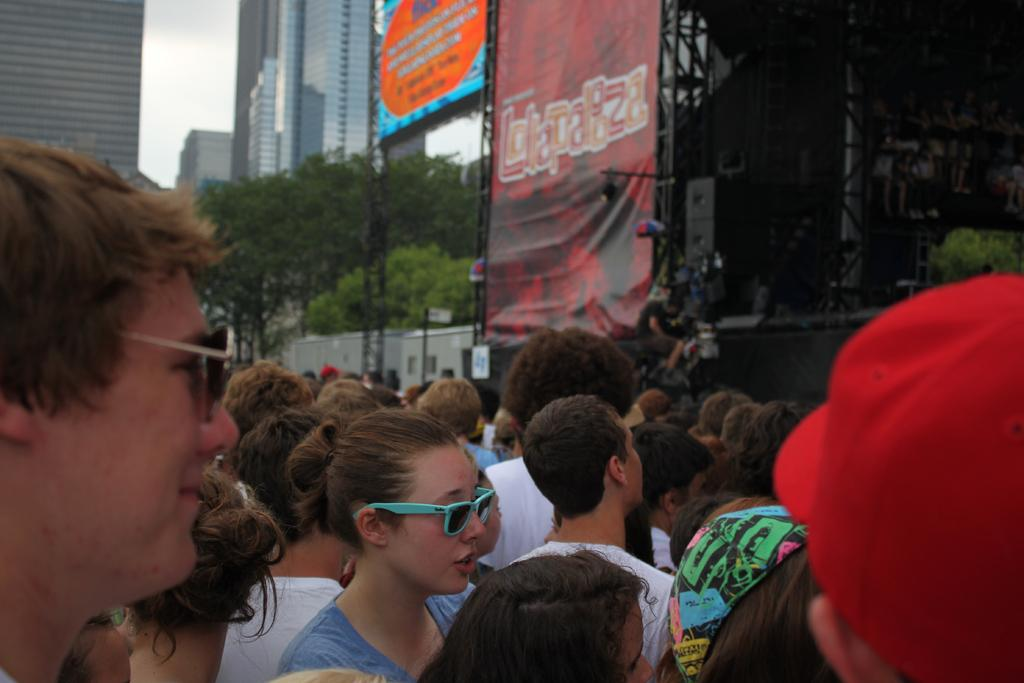How many people are visible at the bottom of the image? There are many people standing at the bottom of the image. What can be seen in the background of the image? There are trees, buildings, rods with posters, and speakers in the background of the image. What year is depicted in the image? The year is not depicted in the image; it is a current scene with people, trees, buildings, rods with posters, and speakers. Can you see a playground in the image? There is no playground visible in the image. 